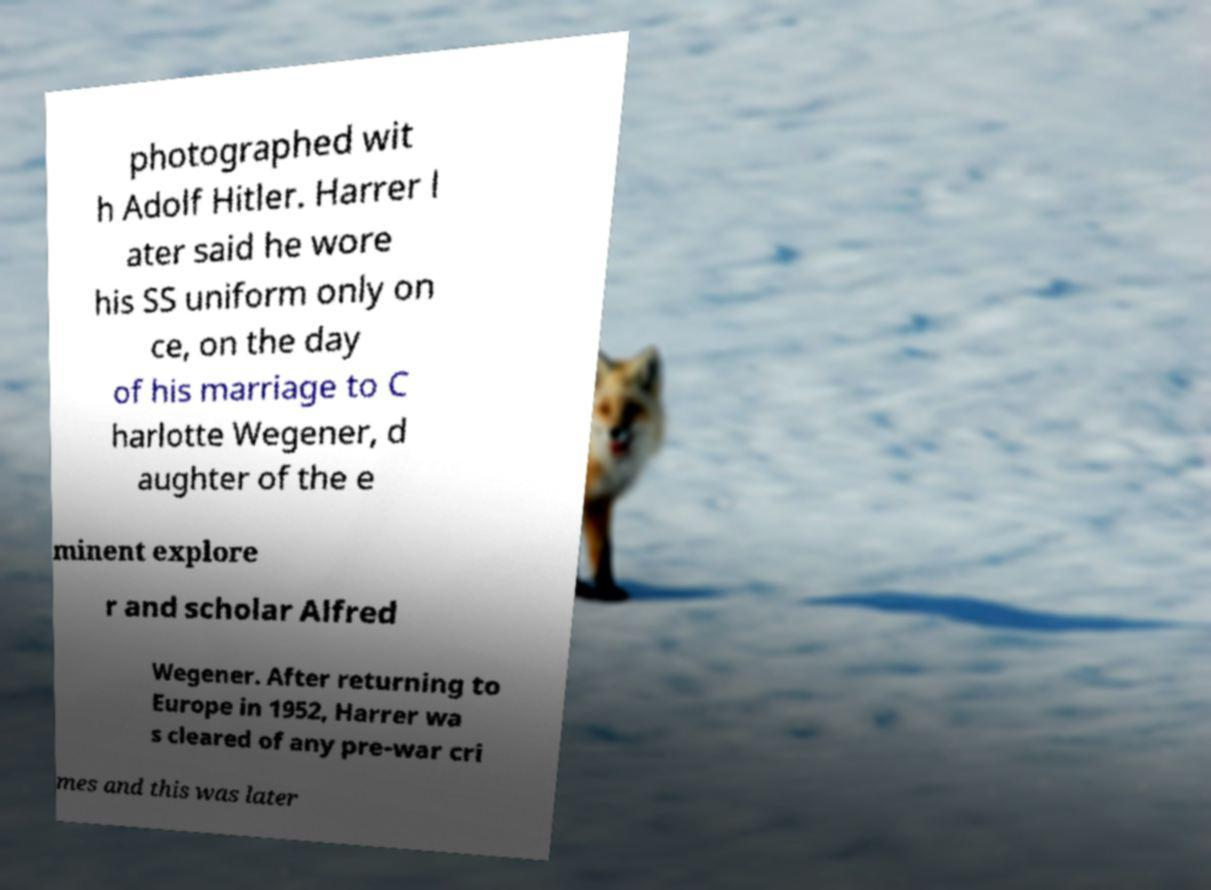Please read and relay the text visible in this image. What does it say? photographed wit h Adolf Hitler. Harrer l ater said he wore his SS uniform only on ce, on the day of his marriage to C harlotte Wegener, d aughter of the e minent explore r and scholar Alfred Wegener. After returning to Europe in 1952, Harrer wa s cleared of any pre-war cri mes and this was later 